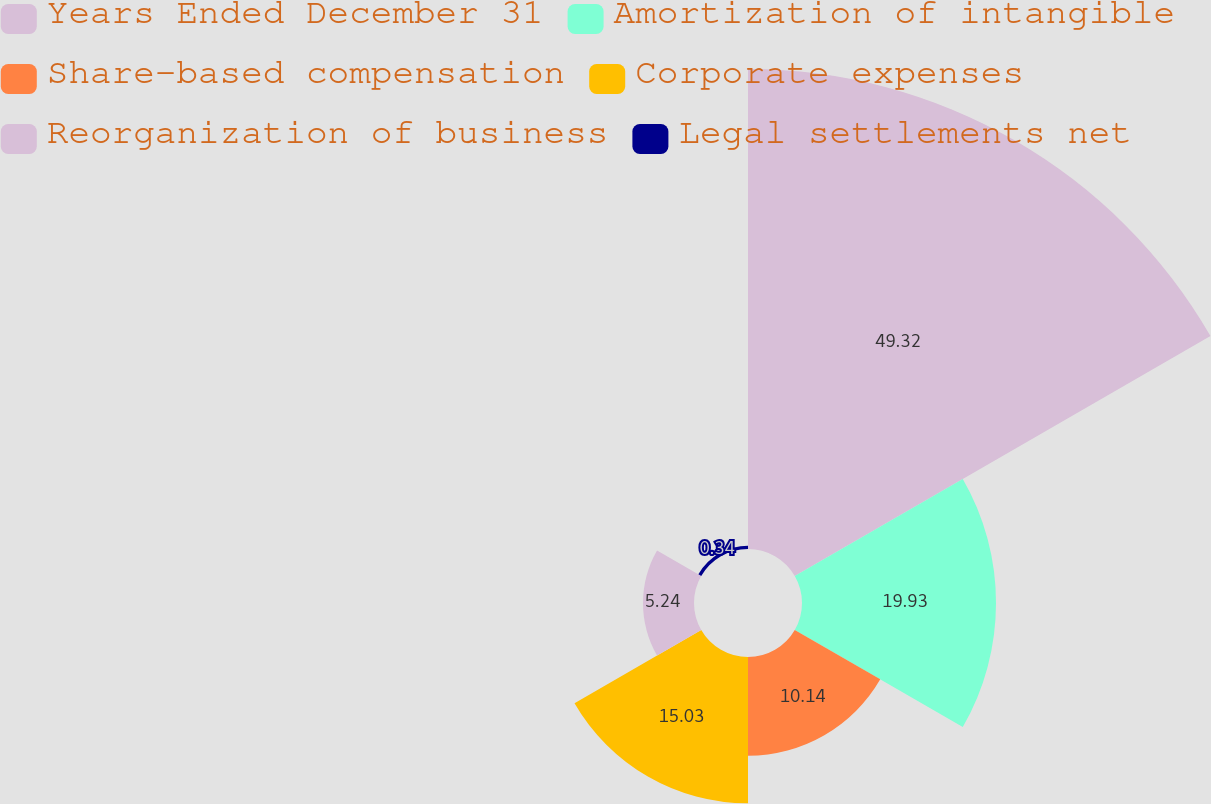Convert chart to OTSL. <chart><loc_0><loc_0><loc_500><loc_500><pie_chart><fcel>Years Ended December 31<fcel>Amortization of intangible<fcel>Share-based compensation<fcel>Corporate expenses<fcel>Reorganization of business<fcel>Legal settlements net<nl><fcel>49.31%<fcel>19.93%<fcel>10.14%<fcel>15.03%<fcel>5.24%<fcel>0.34%<nl></chart> 